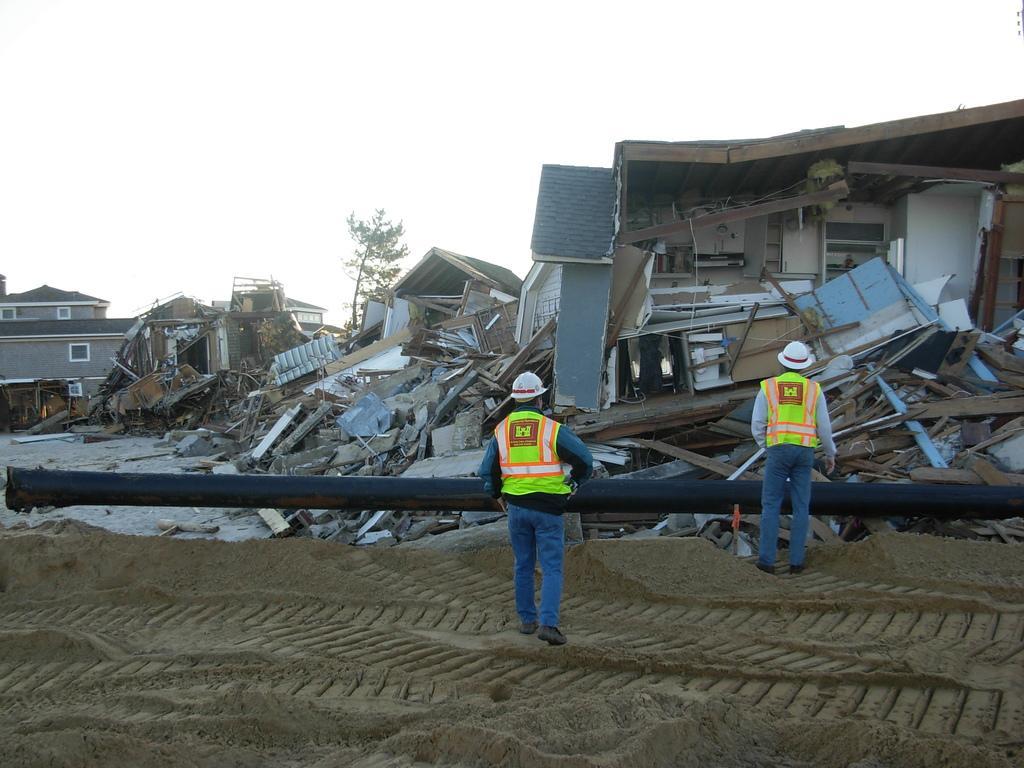Could you give a brief overview of what you see in this image? This image is taken outdoors. At the bottom of the image there is a ground. In the middle of the image there are a few collapsed houses and there is a tree. Two men are standing on the ground and there is a pipe. 